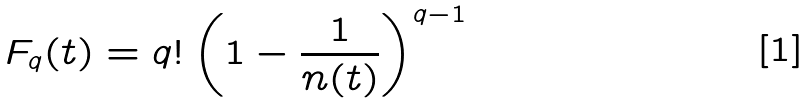<formula> <loc_0><loc_0><loc_500><loc_500>F _ { q } ( t ) = q ! \left ( 1 - \frac { 1 } { n ( t ) } \right ) ^ { q - 1 }</formula> 